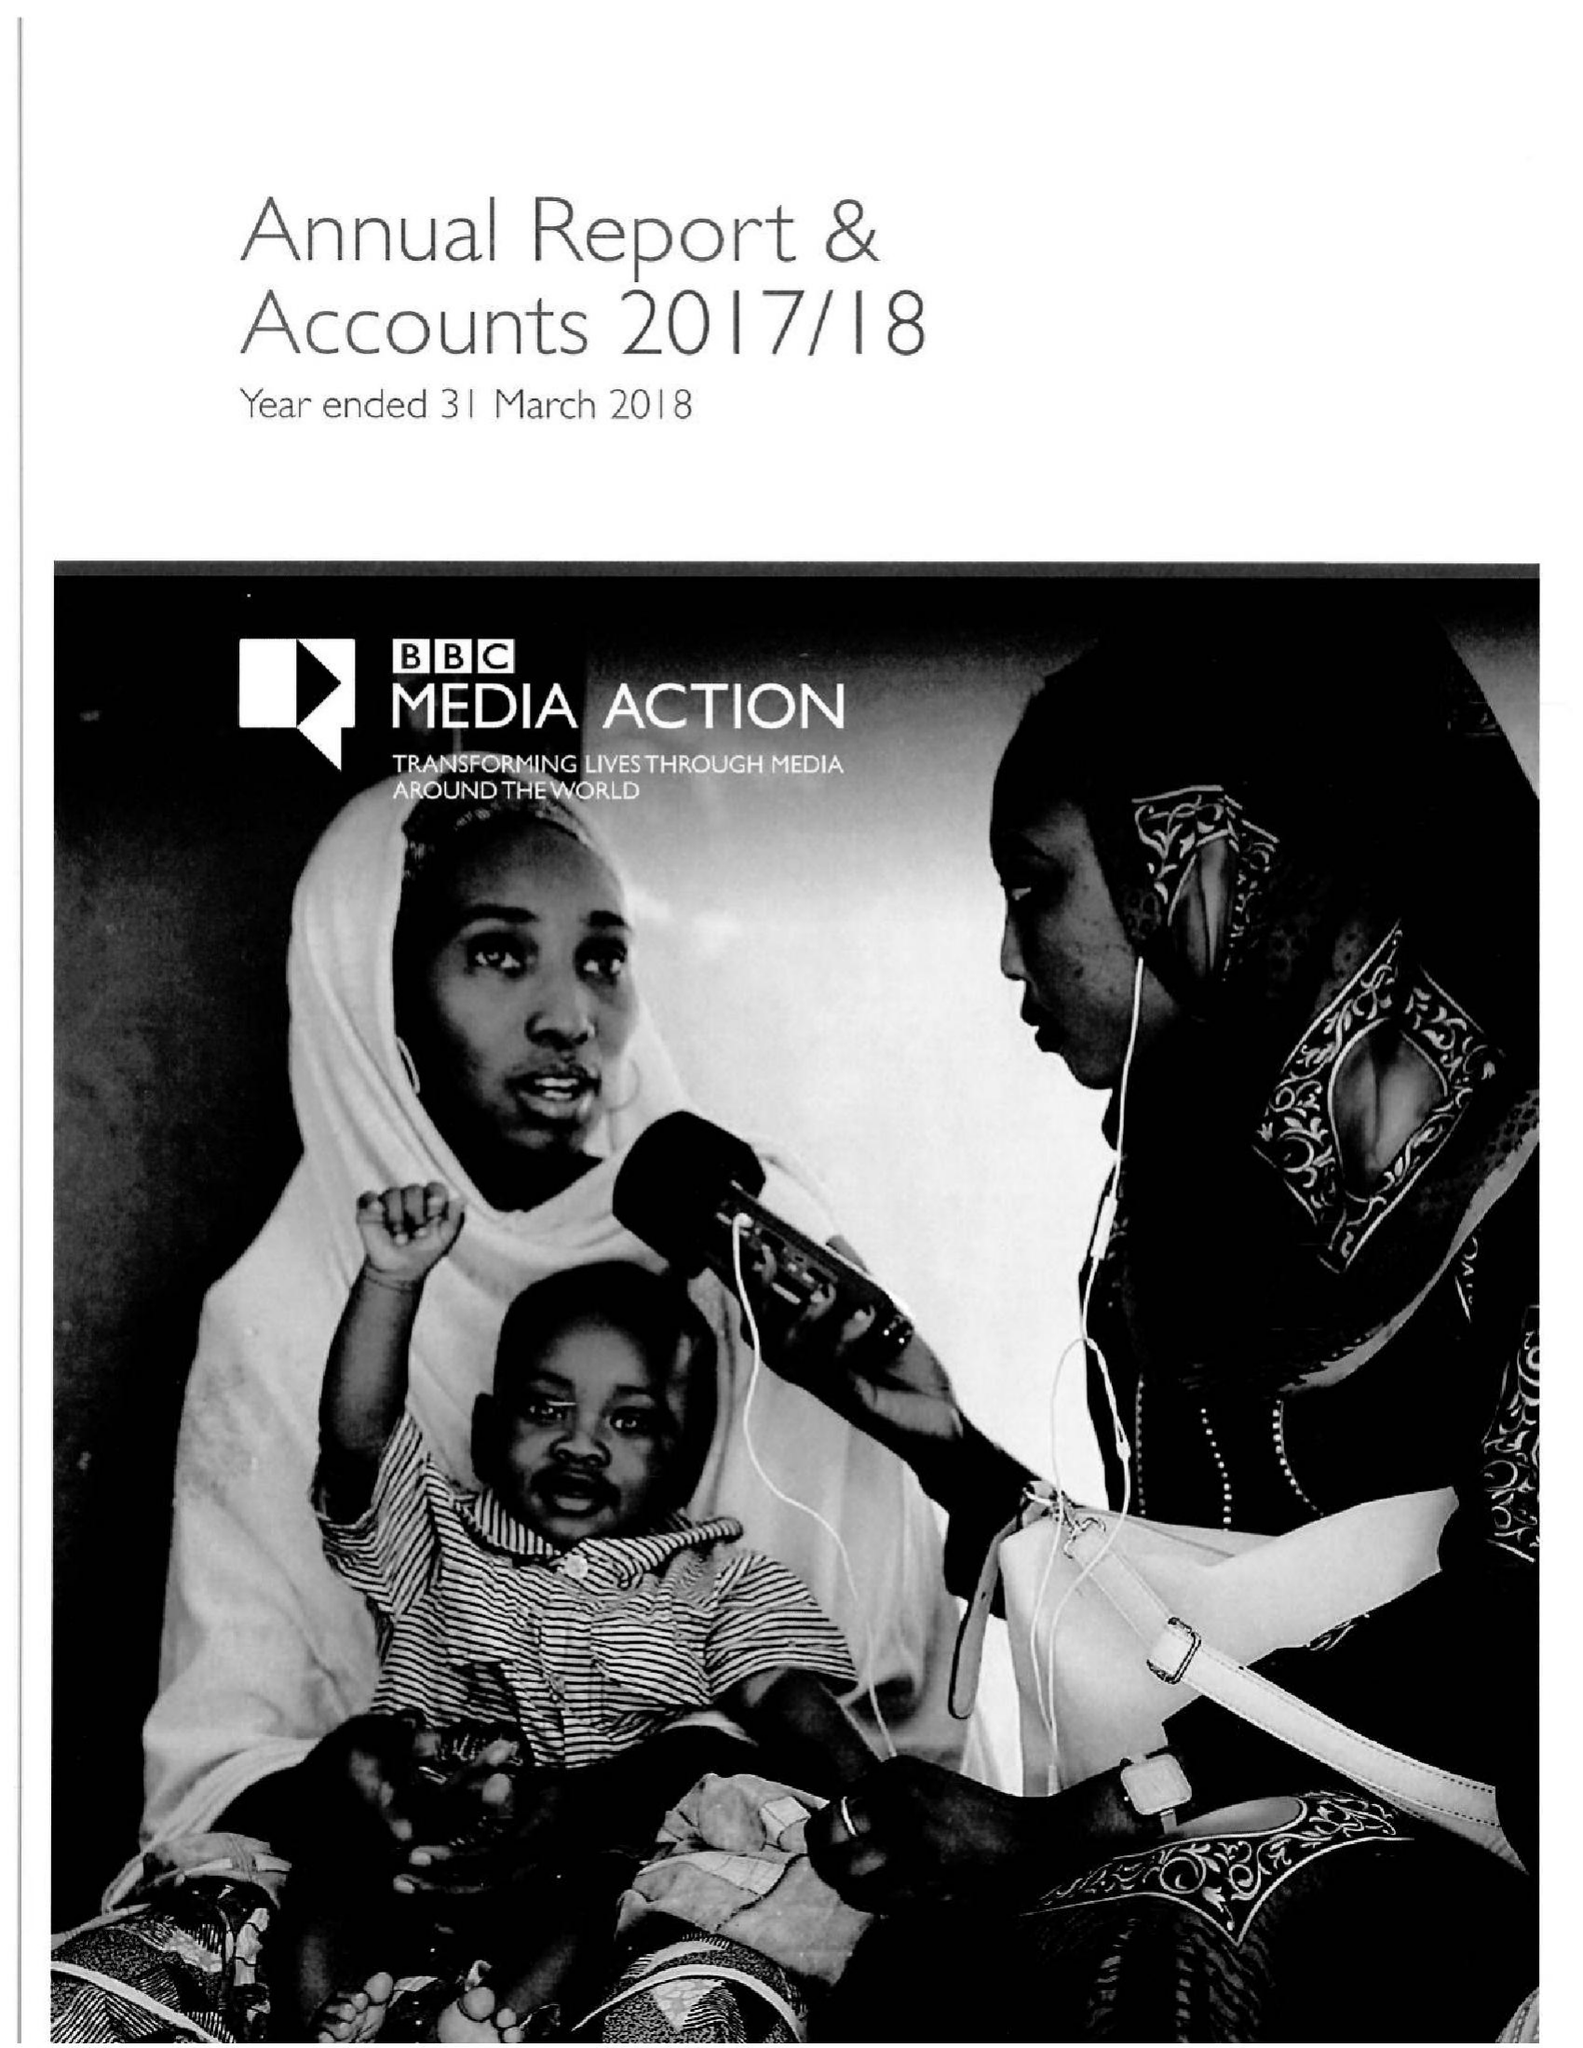What is the value for the spending_annually_in_british_pounds?
Answer the question using a single word or phrase. 35928170.00 